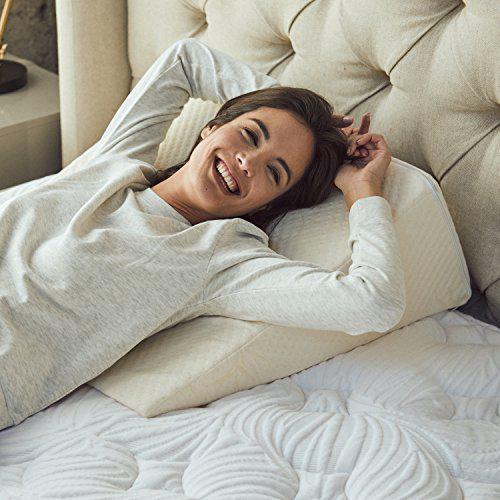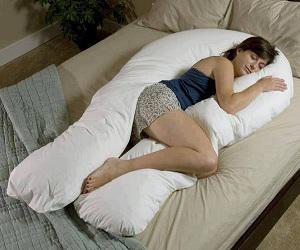The first image is the image on the left, the second image is the image on the right. For the images shown, is this caption "There are fewer than seven pillows visible in total." true? Answer yes or no. Yes. The first image is the image on the left, the second image is the image on the right. Evaluate the accuracy of this statement regarding the images: "The right image shows at least four pillows on a bed with a brown headboard and white bedding.". Is it true? Answer yes or no. No. 